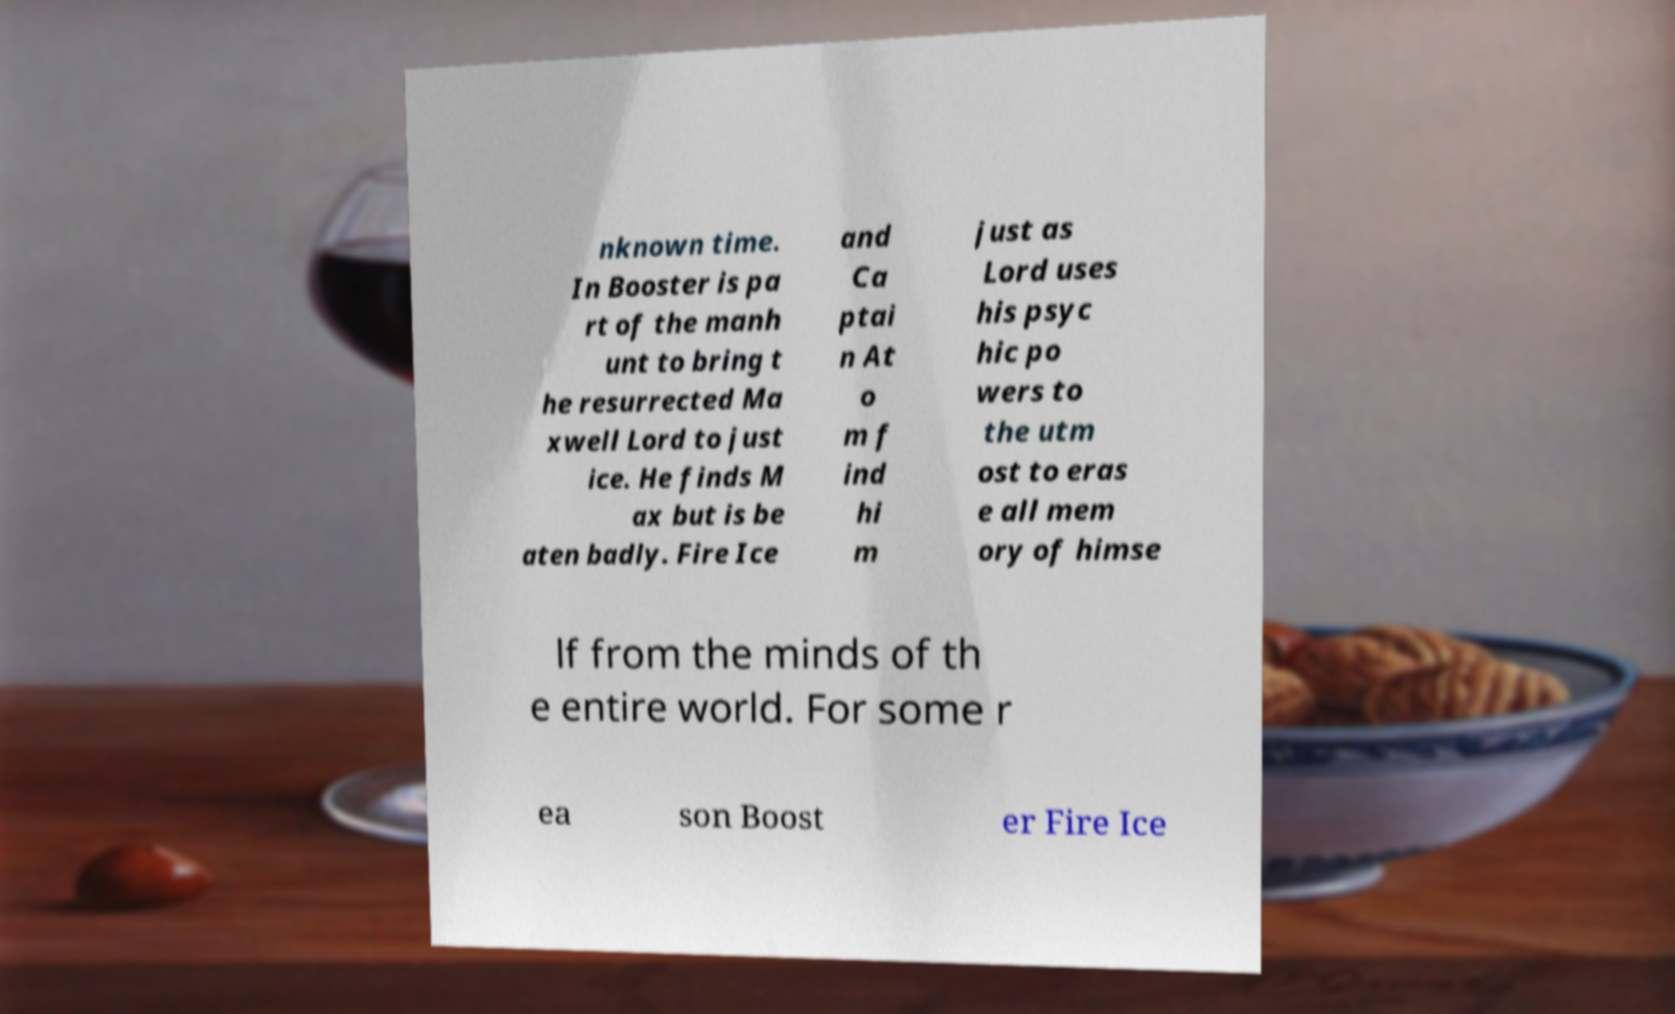There's text embedded in this image that I need extracted. Can you transcribe it verbatim? nknown time. In Booster is pa rt of the manh unt to bring t he resurrected Ma xwell Lord to just ice. He finds M ax but is be aten badly. Fire Ice and Ca ptai n At o m f ind hi m just as Lord uses his psyc hic po wers to the utm ost to eras e all mem ory of himse lf from the minds of th e entire world. For some r ea son Boost er Fire Ice 